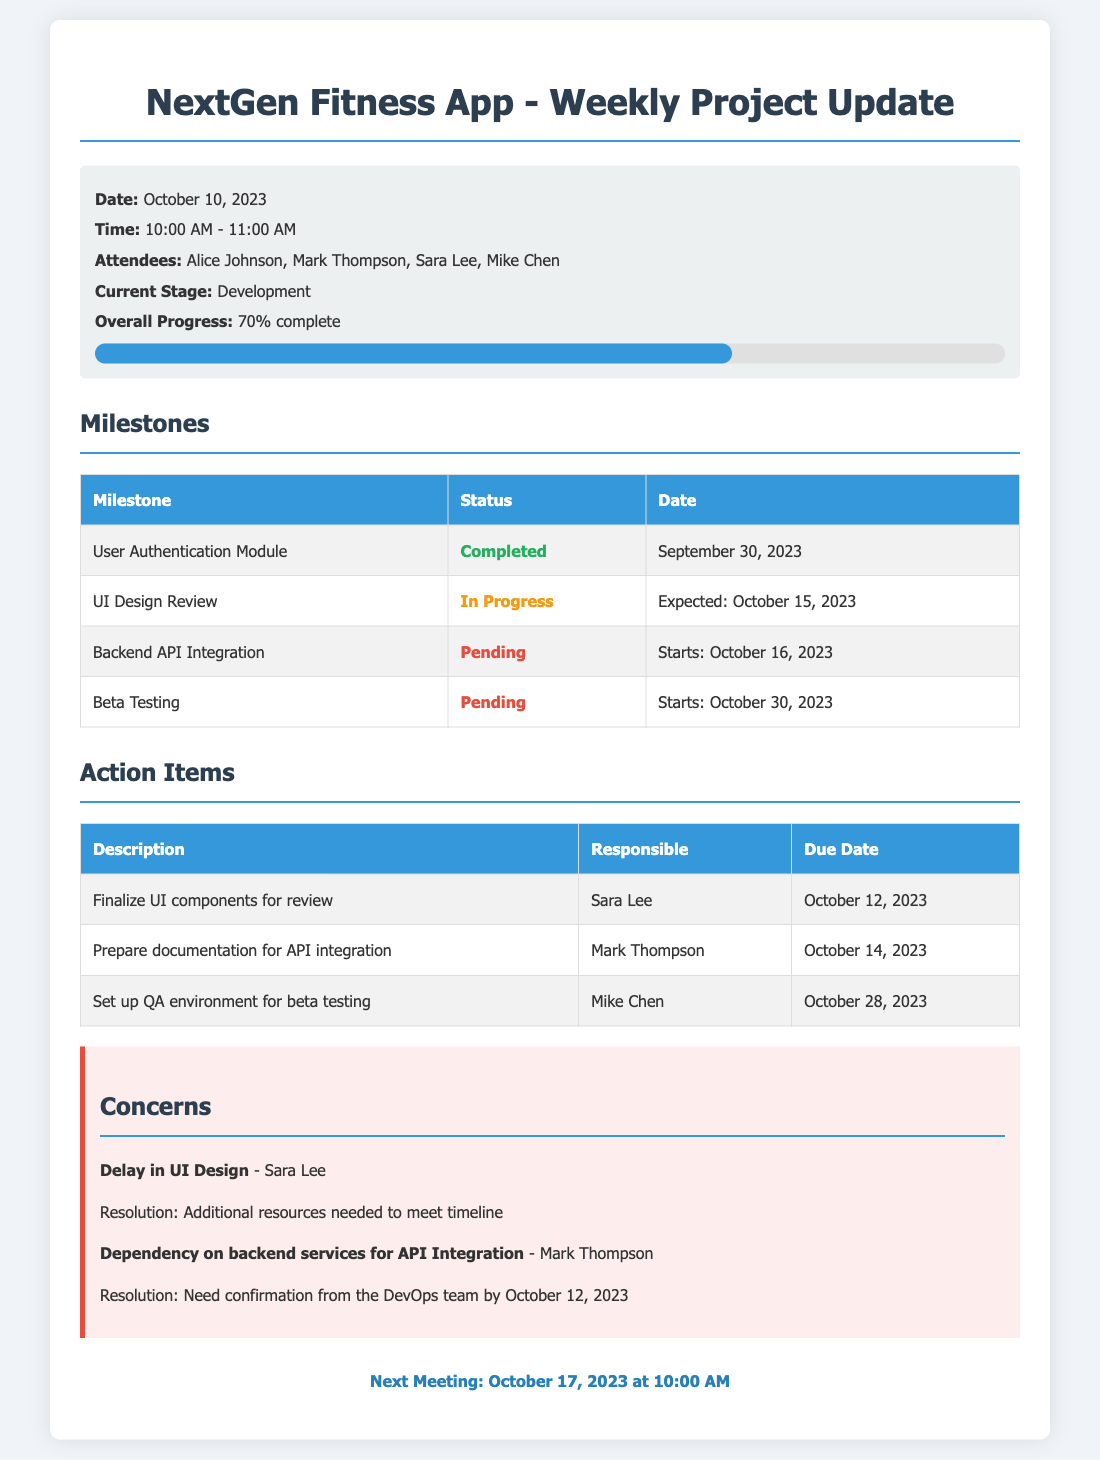What is the overall progress of the project? The overall progress is indicated in the document as 70% complete.
Answer: 70% complete Who is responsible for finalizing UI components for review? The document lists Sara Lee as responsible for this action item.
Answer: Sara Lee What is the expected date for the UI Design Review milestone? The document states that the expected date for the UI Design Review is October 15, 2023.
Answer: October 15, 2023 What is the main concern regarding UI Design? The document highlights a delay in UI Design as the main concern.
Answer: Delay in UI Design When is the next meeting scheduled? The document specifies that the next meeting is on October 17, 2023 at 10:00 AM.
Answer: October 17, 2023 at 10:00 AM Which milestone is pending that involves starting on October 16, 2023? The document indicates that the Backend API Integration milestone is pending and starts on this date.
Answer: Backend API Integration What needs confirmation from the DevOps team by October 12, 2023? The document mentions that there is a dependency on backend services for API Integration that needs confirmation.
Answer: Dependency on backend services for API Integration What date is assigned for setting up the QA environment for beta testing? The due date for setting up the QA environment is mentioned in the document as October 28, 2023.
Answer: October 28, 2023 